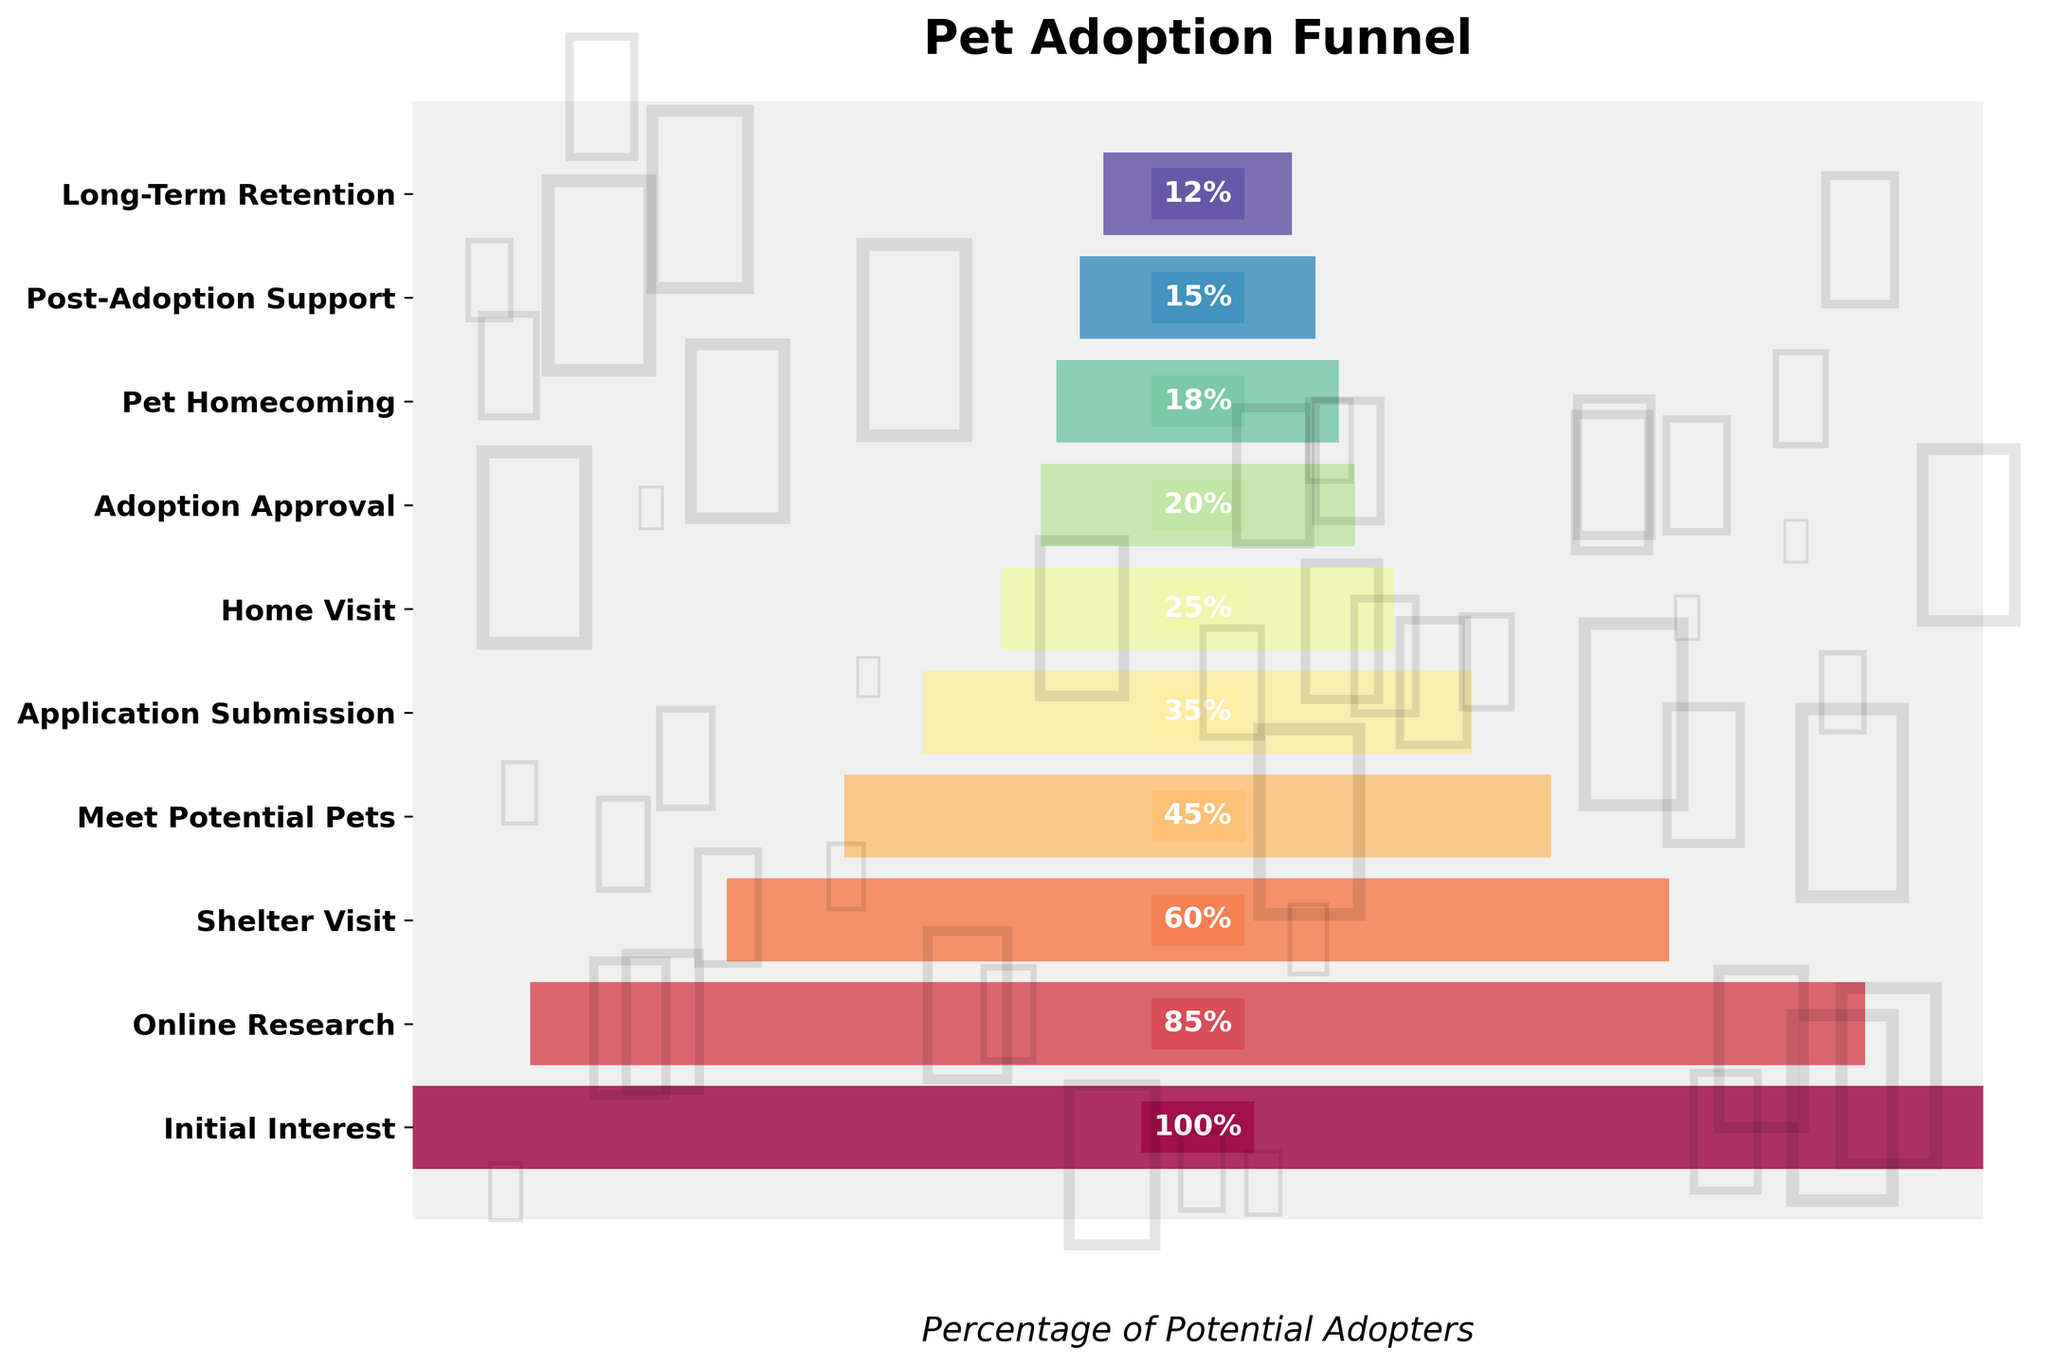What is the title of the funnel chart? The title is the text displayed prominently at the top of the chart, which is usually meant to describe the subject of the figure.
Answer: Pet Adoption Funnel Which stage has the highest percentage? The highest percentage is the one at the widest part of the funnel at the top.
Answer: Initial Interest How many stages are in the pet adoption process shown in the chart? Count the number of unique stages listed on the y-axis.
Answer: 10 What is the percentage for the Shelter Visit stage? Locate the Shelter Visit stage on the y-axis and read the corresponding percentage.
Answer: 60% What is the difference in percentage between Initial Interest and Shelter Visit stages? Subtract the percentage of the Shelter Visit stage from the percentage of the Initial Interest stage (100% - 60%).
Answer: 40% Compare the percentages of Online Research and Home Visit stages. Which one is higher? Locate both stages on the y-axis and compare their corresponding percentages.
Answer: Online Research What stage has a percentage of 25%? Find the stage labeled with 25% on the y-axis.
Answer: Home Visit What is the percentage drop between Application Submission and Adoption Approval stages? Subtract the percentage of Adoption Approval from Application Submission (35% - 20%).
Answer: 15% Based on the funnel chart, how much does the percentage drop from the start to the end of the pet adoption process? Subtract the percentage at the Pet Homecoming stage from the percentage at the Initial Interest stage (100% - 12%).
Answer: 88% Does the color intensity change as we move down the stages of the funnel chart? Observe the color changes from the top to the bottom of the funnel chart.
Answer: Yes 